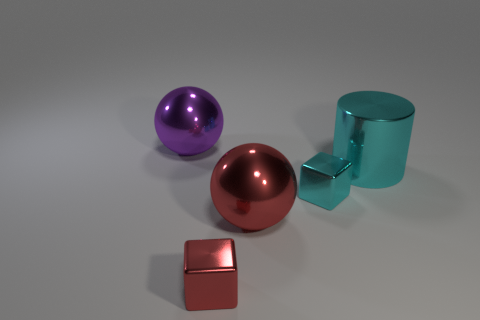What color is the sphere in front of the large ball that is behind the cyan cylinder?
Provide a short and direct response. Red. How big is the sphere to the right of the big metallic ball behind the large cyan metallic cylinder?
Your answer should be very brief. Large. There is a cube that is the same color as the big shiny cylinder; what is its size?
Your answer should be very brief. Small. How many other objects are there of the same size as the cylinder?
Offer a terse response. 2. The big shiny ball behind the big sphere that is in front of the big shiny sphere behind the large metallic cylinder is what color?
Ensure brevity in your answer.  Purple. How many other objects are there of the same shape as the large cyan metal object?
Give a very brief answer. 0. What is the shape of the big thing to the right of the tiny cyan metallic object?
Provide a succinct answer. Cylinder. There is a cyan metal thing that is left of the large shiny cylinder; is there a big thing that is on the left side of it?
Your answer should be compact. Yes. There is a large metallic object that is both right of the red metal block and behind the large red ball; what is its color?
Give a very brief answer. Cyan. There is a large metal thing right of the cyan metallic thing that is in front of the big cyan cylinder; is there a big red shiny object in front of it?
Offer a very short reply. Yes. 